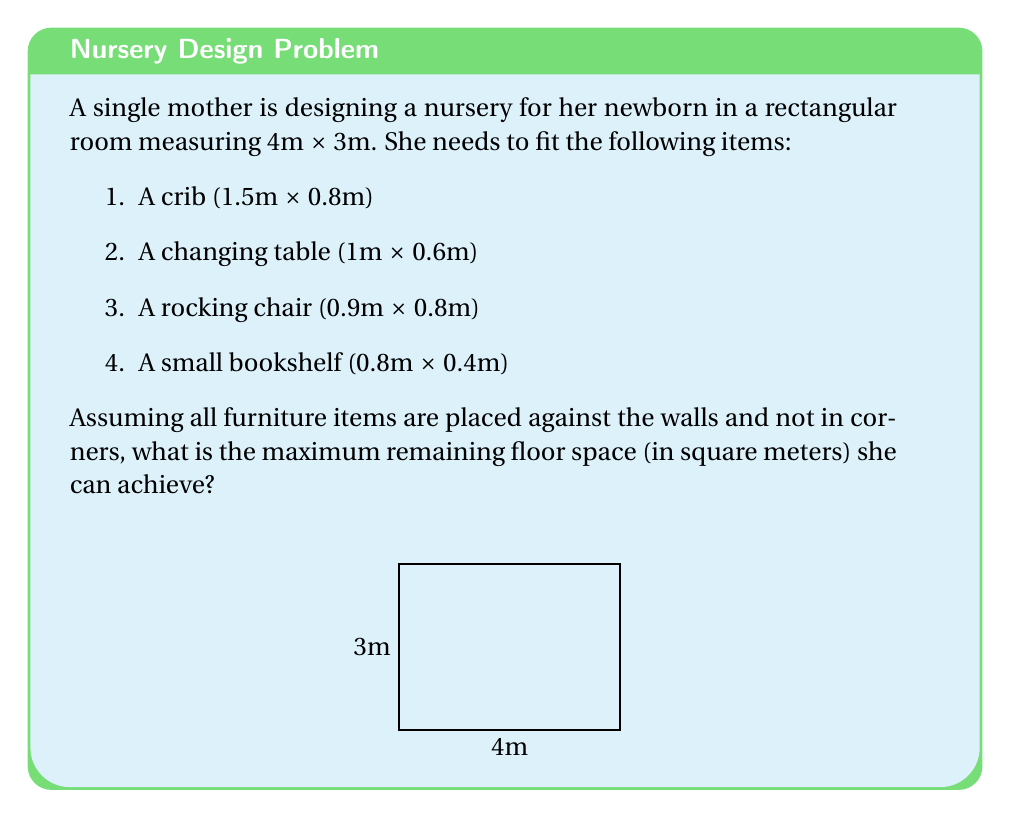Provide a solution to this math problem. Let's approach this step-by-step:

1. Calculate the total room area:
   $A_{room} = 4m \times 3m = 12m^2$

2. Calculate the area occupied by each furniture item:
   - Crib: $A_{crib} = 1.5m \times 0.8m = 1.2m^2$
   - Changing table: $A_{table} = 1m \times 0.6m = 0.6m^2$
   - Rocking chair: $A_{chair} = 0.9m \times 0.8m = 0.72m^2$
   - Bookshelf: $A_{shelf} = 0.8m \times 0.4m = 0.32m^2$

3. Sum up the total area occupied by furniture:
   $A_{furniture} = 1.2m^2 + 0.6m^2 + 0.72m^2 + 0.32m^2 = 2.84m^2$

4. However, since the furniture is placed against the walls, we need to consider the full length of each item rather than its area. The total perimeter of the room is:
   $P_{room} = 2 \times (4m + 3m) = 14m$

5. The total length of furniture along the walls is:
   $L_{furniture} = 1.5m + 1m + 0.9m + 0.8m = 4.2m$

6. The remaining wall space is:
   $L_{remaining} = 14m - 4.2m = 9.8m$

7. To maximize floor space, we place the furniture in a way that minimizes intrusion into the room. The intrusion depth for each item is:
   - Crib: 0.8m
   - Changing table: 0.6m
   - Rocking chair: 0.8m
   - Bookshelf: 0.4m

8. The maximum intrusion is 0.8m. This creates a border of 0.8m along two adjacent walls, leaving a rectangular free space of:
   $(4m - 0.8m) \times (3m - 0.8m) = 3.2m \times 2.2m = 7.04m^2$

Therefore, the maximum remaining floor space is $7.04m^2$.
Answer: $7.04m^2$ 